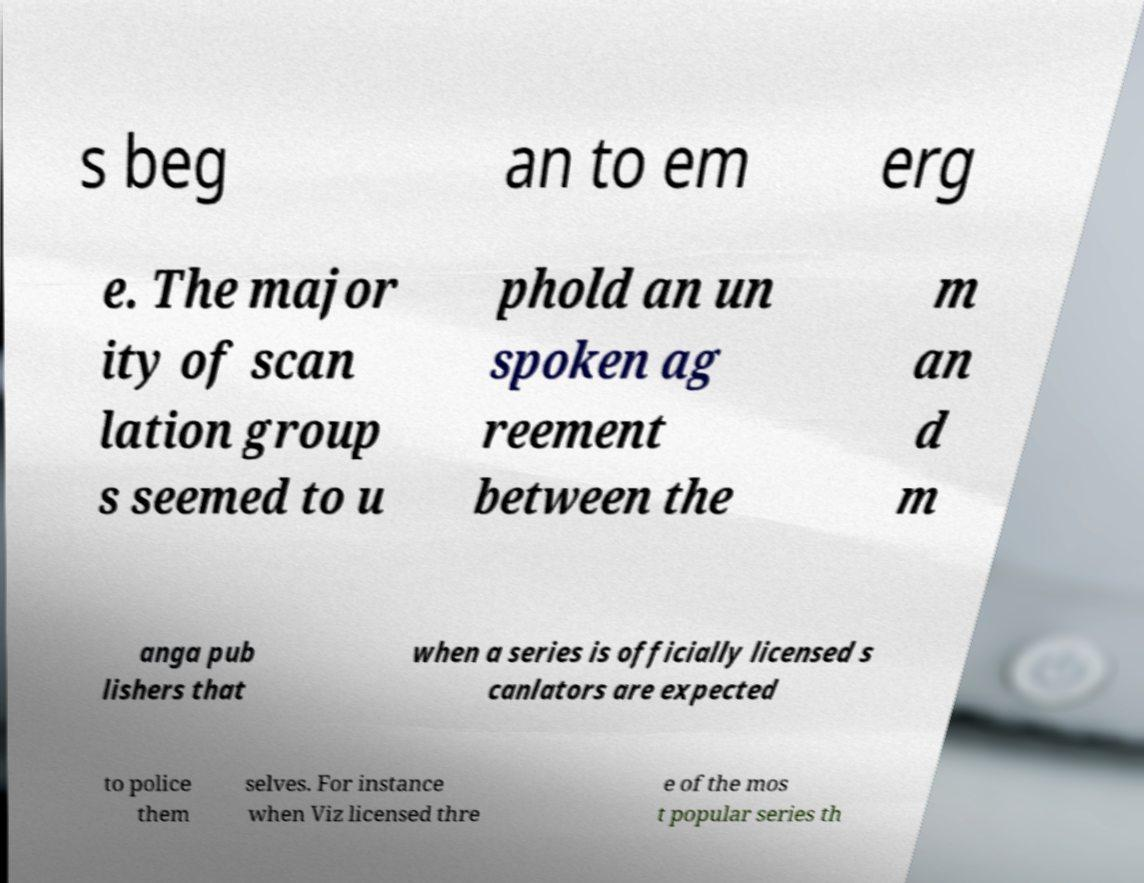Please read and relay the text visible in this image. What does it say? s beg an to em erg e. The major ity of scan lation group s seemed to u phold an un spoken ag reement between the m an d m anga pub lishers that when a series is officially licensed s canlators are expected to police them selves. For instance when Viz licensed thre e of the mos t popular series th 